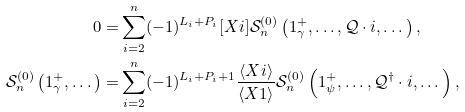Convert formula to latex. <formula><loc_0><loc_0><loc_500><loc_500>0 = & \sum _ { i = 2 } ^ { n } ( - 1 ) ^ { L _ { i } + P _ { i } } [ X i ] \mathcal { S } ^ { ( 0 ) } _ { n } \left ( 1 _ { \gamma } ^ { + } , \dots , \mathcal { Q } \cdot i , \dots \right ) , \\ \mathcal { S } _ { n } ^ { ( 0 ) } \left ( 1 _ { \gamma } ^ { + } , \dots \right ) = & \sum _ { i = 2 } ^ { n } ( - 1 ) ^ { L _ { i } + P _ { i } + 1 } \frac { \langle X i \rangle } { \langle X 1 \rangle } \mathcal { S } ^ { ( 0 ) } _ { n } \left ( 1 _ { \psi } ^ { + } , \dots , \mathcal { Q } ^ { \dagger } \cdot i , \dots \right ) ,</formula> 